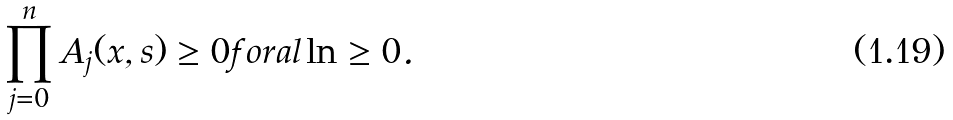<formula> <loc_0><loc_0><loc_500><loc_500>\prod _ { j = 0 } ^ { n } A _ { j } ( x , s ) \geq 0 f o r a l \ln \geq 0 .</formula> 